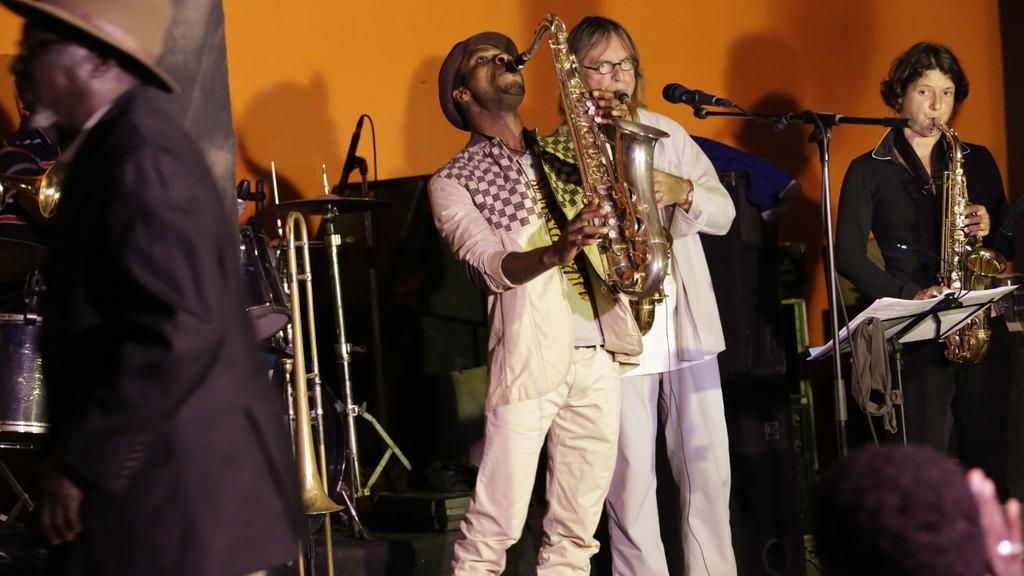How many people are playing musical instruments in the image? There are three members playing musical instruments in the image. Can you describe the person on the left side of the image? The person on the left side of the image is wearing a hat. What can be seen in the background of the image? There is a wall in the background of the image. What type of root can be seen growing out of the wall in the image? There is no root growing out of the wall in the image; only a wall is visible in the background. Can you describe the snail crawling on the person wearing the hat? There is no snail present in the image; the person on the left side of the image is wearing a hat, but there are no snails or other animals visible. 